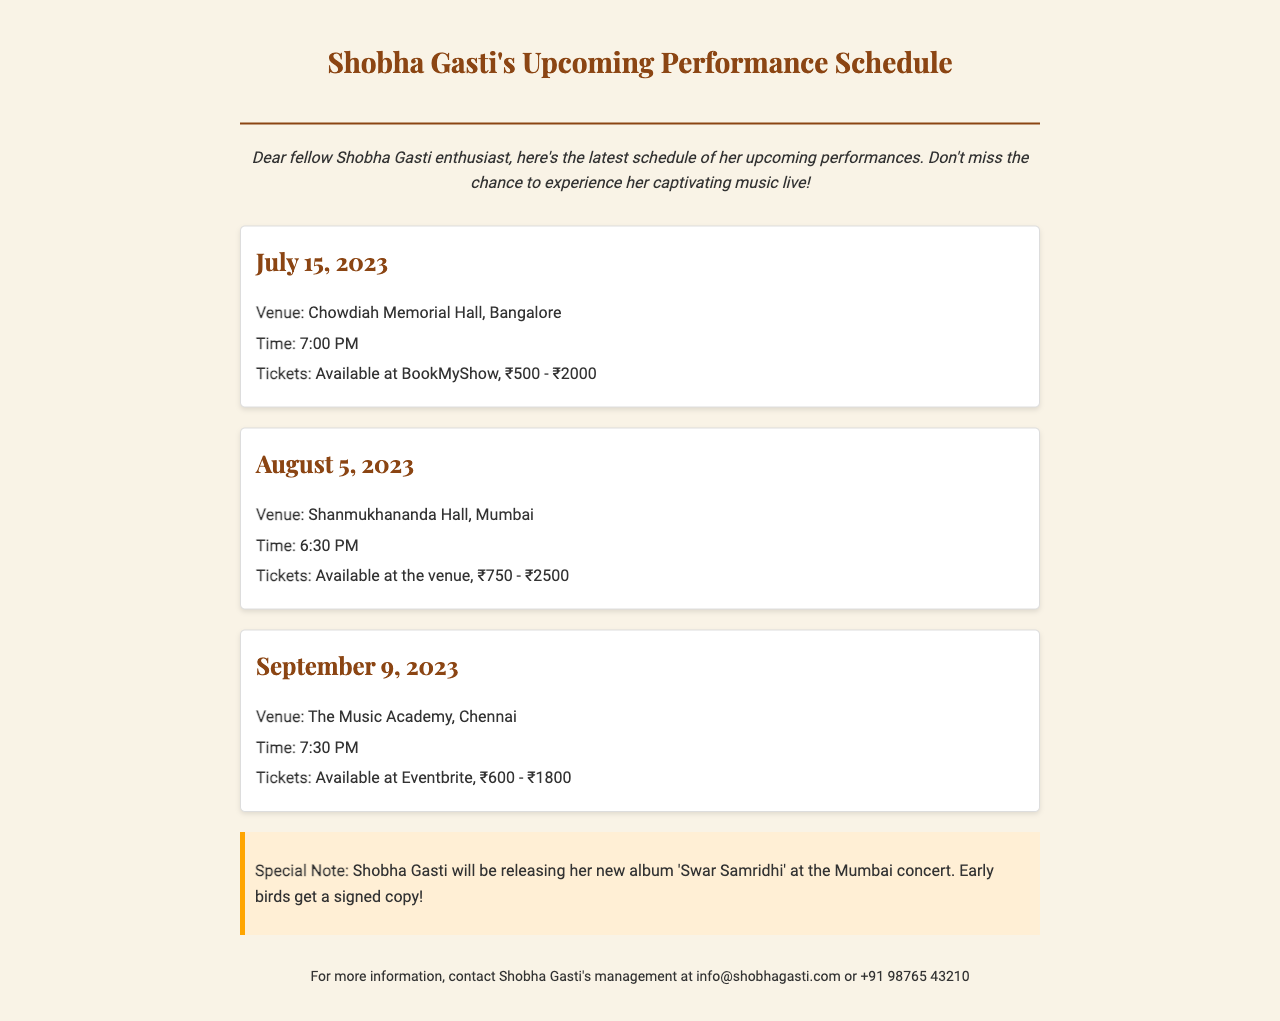What is the date of the concert in Bangalore? The concert in Bangalore is scheduled for July 15, 2023.
Answer: July 15, 2023 What is the venue for the Mumbai performance? The venue for the Mumbai performance is Shanmukhananda Hall.
Answer: Shanmukhananda Hall What time does the Chennai concert start? The concert in Chennai starts at 7:30 PM.
Answer: 7:30 PM How much do tickets for the Bangalore concert cost? Tickets for the Bangalore concert cost between ₹500 - ₹2000.
Answer: ₹500 - ₹2000 What special event will happen at the Mumbai concert? At the Mumbai concert, Shobha Gasti will release her new album 'Swar Samridhi'.
Answer: Album release What is the range of ticket prices for the Chennai performance? The ticket prices for the Chennai performance range from ₹600 - ₹1800.
Answer: ₹600 - ₹1800 Who can you contact for more information? For more information, you can contact Shobha Gasti's management.
Answer: Shobha Gasti's management What is the maximum ticket price for the Mumbai concert? The maximum ticket price for the Mumbai concert is ₹2500.
Answer: ₹2500 Where can tickets be purchased for the Chennai concert? Tickets for the Chennai concert can be purchased at Eventbrite.
Answer: Eventbrite 